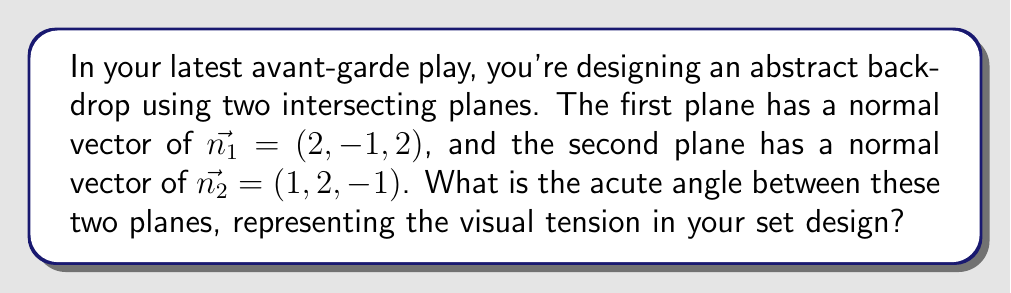Help me with this question. To find the angle between two intersecting planes, we can use the dot product of their normal vectors. The formula for the angle $\theta$ between two planes with normal vectors $\vec{n_1}$ and $\vec{n_2}$ is:

$$\cos \theta = \frac{|\vec{n_1} \cdot \vec{n_2}|}{\|\vec{n_1}\| \|\vec{n_2}\|}$$

Step 1: Calculate the dot product $\vec{n_1} \cdot \vec{n_2}$
$$\vec{n_1} \cdot \vec{n_2} = (2)(1) + (-1)(2) + (2)(-1) = 2 - 2 - 2 = -2$$

Step 2: Calculate the magnitudes of $\vec{n_1}$ and $\vec{n_2}$
$$\|\vec{n_1}\| = \sqrt{2^2 + (-1)^2 + 2^2} = \sqrt{9} = 3$$
$$\|\vec{n_2}\| = \sqrt{1^2 + 2^2 + (-1)^2} = \sqrt{6}$$

Step 3: Apply the formula
$$\cos \theta = \frac{|-2|}{3\sqrt{6}} = \frac{2}{3\sqrt{6}}$$

Step 4: Take the inverse cosine (arccos) of both sides
$$\theta = \arccos(\frac{2}{3\sqrt{6}})$$

Step 5: Calculate the result (in radians)
$$\theta \approx 1.3181$$

Step 6: Convert to degrees
$$\theta \approx 75.52°$$

This is the acute angle between the planes. The obtuse angle would be $180° - 75.52° = 104.48°$.
Answer: $75.52°$ 